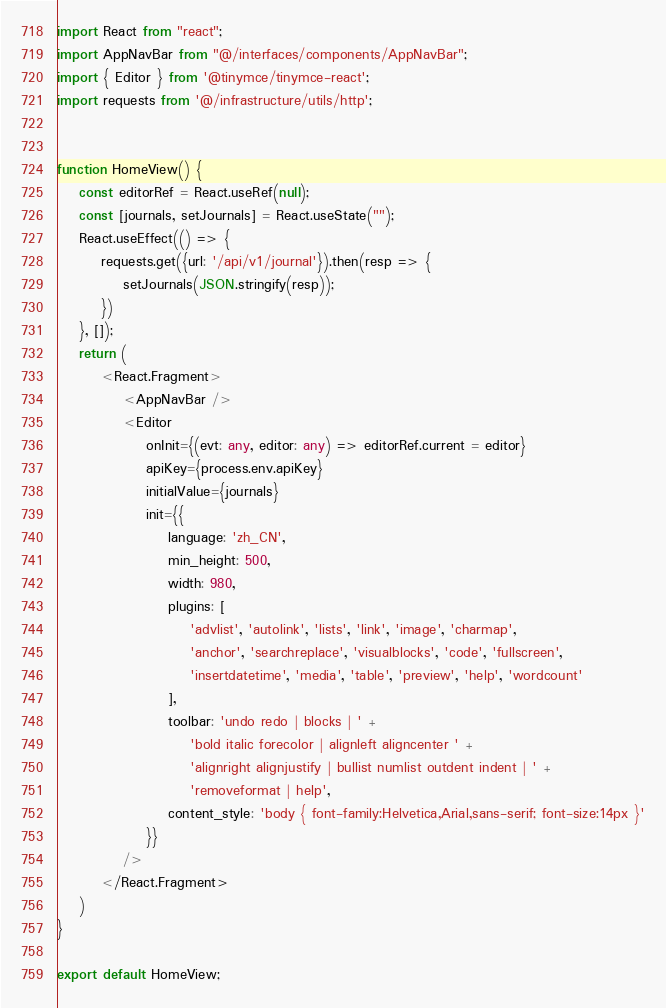<code> <loc_0><loc_0><loc_500><loc_500><_TypeScript_>import React from "react";
import AppNavBar from "@/interfaces/components/AppNavBar";
import { Editor } from '@tinymce/tinymce-react';
import requests from '@/infrastructure/utils/http';


function HomeView() {
	const editorRef = React.useRef(null);
	const [journals, setJournals] = React.useState("");
	React.useEffect(() => {
		requests.get({url: '/api/v1/journal'}).then(resp => {
			setJournals(JSON.stringify(resp));
		})
	}, []);
	return (
		<React.Fragment>
			<AppNavBar />
			<Editor
				onInit={(evt: any, editor: any) => editorRef.current = editor}
				apiKey={process.env.apiKey}
				initialValue={journals}
				init={{
					language: 'zh_CN',
					min_height: 500,
					width: 980,
					plugins: [
						'advlist', 'autolink', 'lists', 'link', 'image', 'charmap',
						'anchor', 'searchreplace', 'visualblocks', 'code', 'fullscreen',
						'insertdatetime', 'media', 'table', 'preview', 'help', 'wordcount'
					],
					toolbar: 'undo redo | blocks | ' +
						'bold italic forecolor | alignleft aligncenter ' +
						'alignright alignjustify | bullist numlist outdent indent | ' +
						'removeformat | help',
					content_style: 'body { font-family:Helvetica,Arial,sans-serif; font-size:14px }'
				}}
			/>
		</React.Fragment>
	)
}

export default HomeView;</code> 